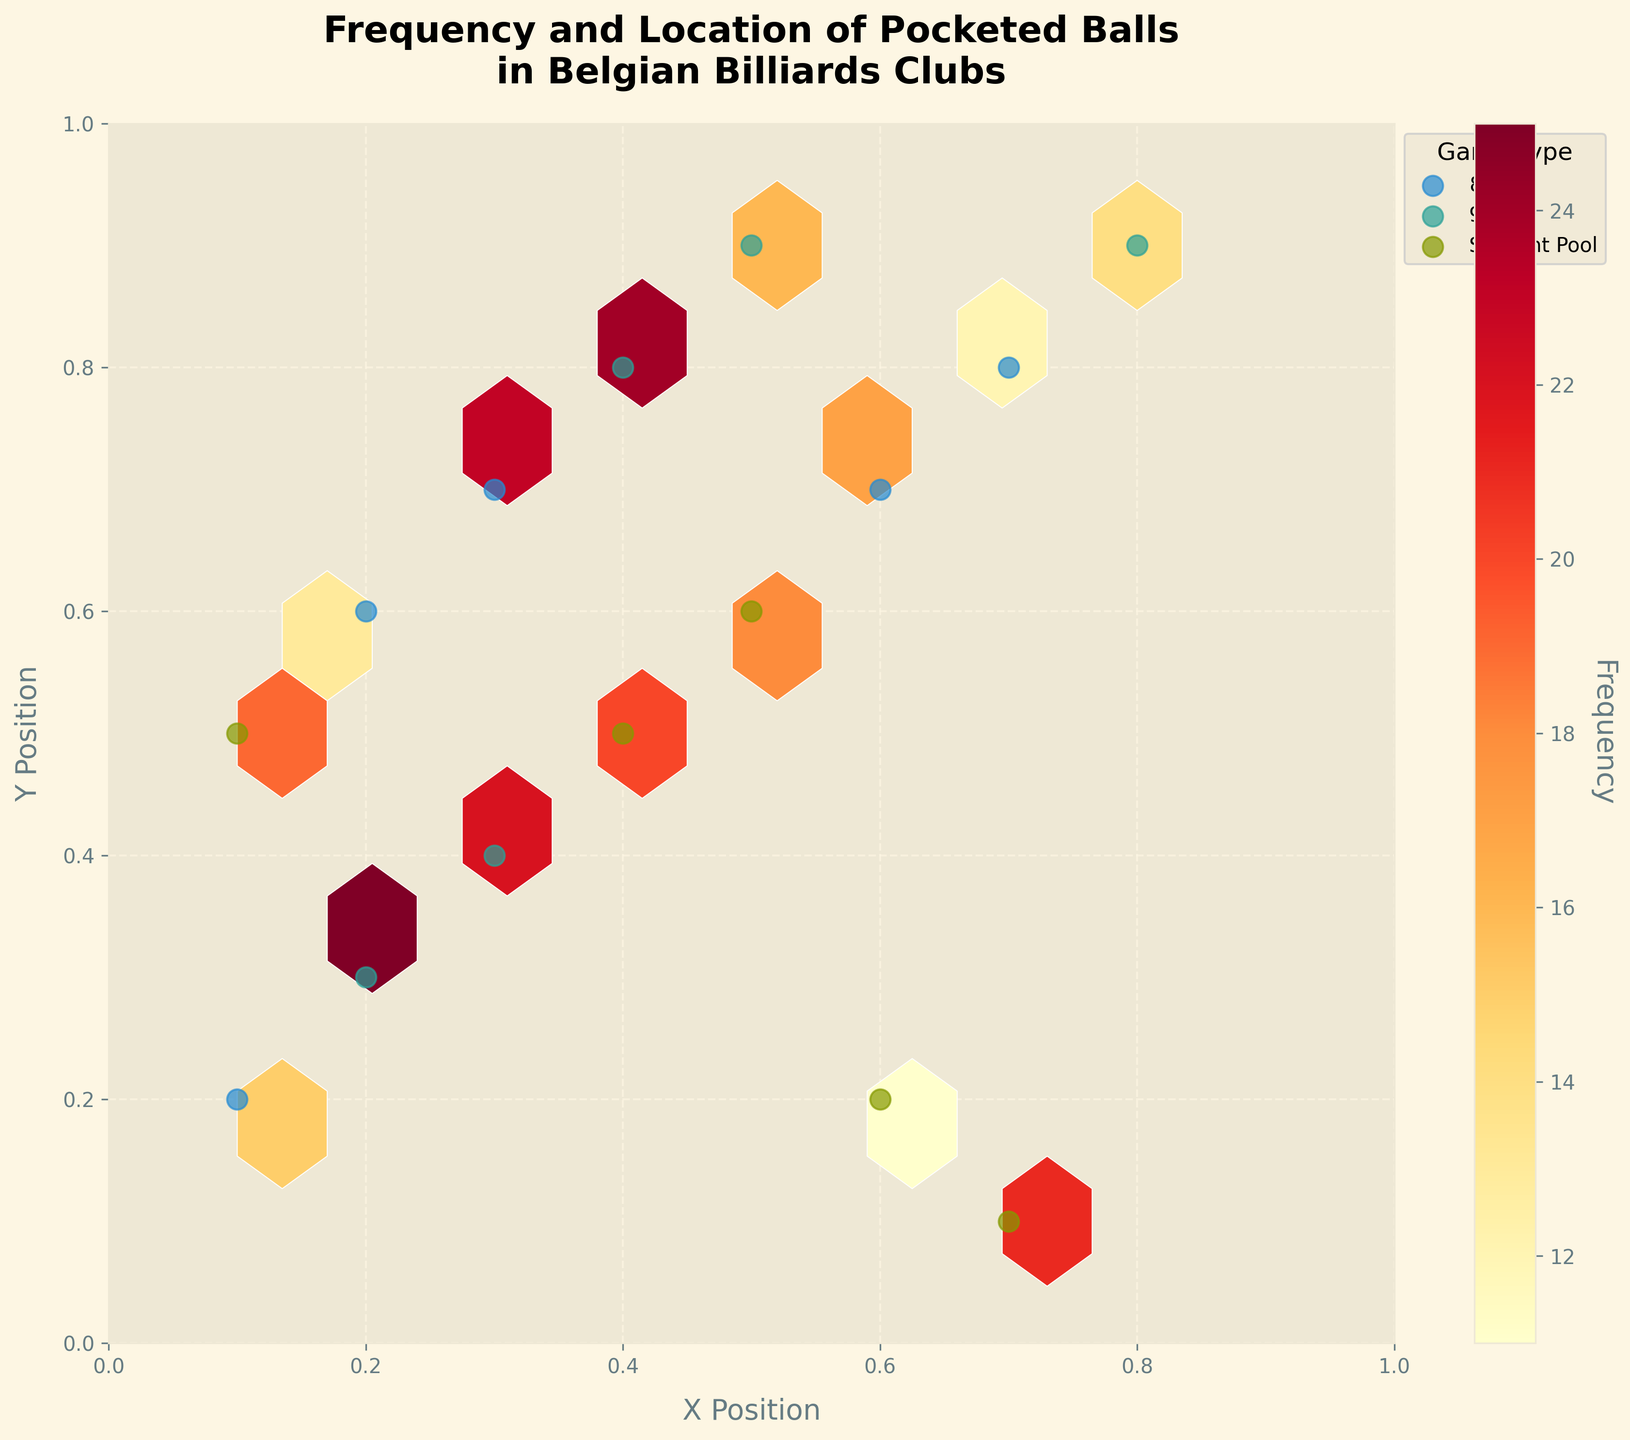What's the title of the figure? The title of the figure is usually displayed at the top, and it summarizes the content of the figure. In this case, the title is present at the top as a formatted string.
Answer: Frequency and Location of Pocketed Balls in Belgian Billiards Clubs What are the labels of the X and Y axes? The labels of the X and Y axes provide context for what each axis represents. Here, they are specified as part of the plot configuration.
Answer: X Position, Y Position How many game types are represented in the figure? To determine the number of game types, one needs to look at the legend of the plot, which lists distinct game types. According to the figure, there are three game types shown in the legend.
Answer: 3 Which game type has the maximum number of scatter points on the plot? To identify the game type with the most scatter points, one must count the scatter points for each game type from the legend. This requires visual scanning of the respective points.
Answer: 8-Ball What is the color scheme used in the hexbin plot? The color scheme indicates the range of colors used to represent the frequency. By checking the colormap settings in the legend, it says 'YlOrRd,' which stands for yellow, orange, and red.
Answer: Yellow to Red (YlOrRd) Are the edges of the hexagons in the plot distinct? You can determine this by looking closely at the hexagons in the plot. The plot configuration uses white edges, making them distinct against the hexagon colors.
Answer: Yes, they are white Which hexagon shows the highest frequency value? To find this, look at the hexagon colors and match them to the color bar legend to find the highest frequency range. The hexagon in the darker shade typically indicates the highest value.
Answer: Hexagon in darker red, near coordinates (0.2, 0.3) Compare the frequencies of pocketed balls in 8-Ball and 9-Ball games. Which has a higher total frequency? Sum the frequencies of hexagons related to 8-Ball and 9-Ball by examining the color bar values and associated scatter points for each game type.
Answer: 9-Ball What range does the color bar indicate for frequency values? By examining the color bar closely, you can read the numeric range it spans from the lowest to the highest value, indicating the frequency of pocketed balls.
Answer: Between 10 and 25 Are there more pocketed balls positioned along the x=0.2 or x=0.7 line? Check the number of scatter points and hexagon frequencies along these vertical lines. Count the points and sum the frequencies for each line.
Answer: x = 0.7 